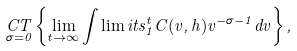Convert formula to latex. <formula><loc_0><loc_0><loc_500><loc_500>\underset { \sigma = 0 } { C T } \left \{ \lim _ { t \to \infty } \int \lim i t s _ { 1 } ^ { t } C ( v , h ) v ^ { - \sigma - 1 } d v \right \} ,</formula> 